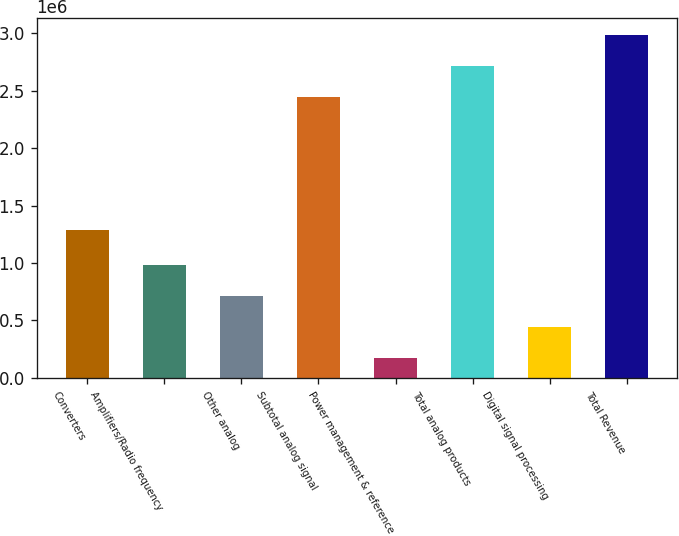<chart> <loc_0><loc_0><loc_500><loc_500><bar_chart><fcel>Converters<fcel>Amplifiers/Radio frequency<fcel>Other analog<fcel>Subtotal analog signal<fcel>Power management & reference<fcel>Total analog products<fcel>Digital signal processing<fcel>Total Revenue<nl><fcel>1.28537e+06<fcel>981570<fcel>712541<fcel>2.44875e+06<fcel>174483<fcel>2.71778e+06<fcel>443512<fcel>2.98681e+06<nl></chart> 